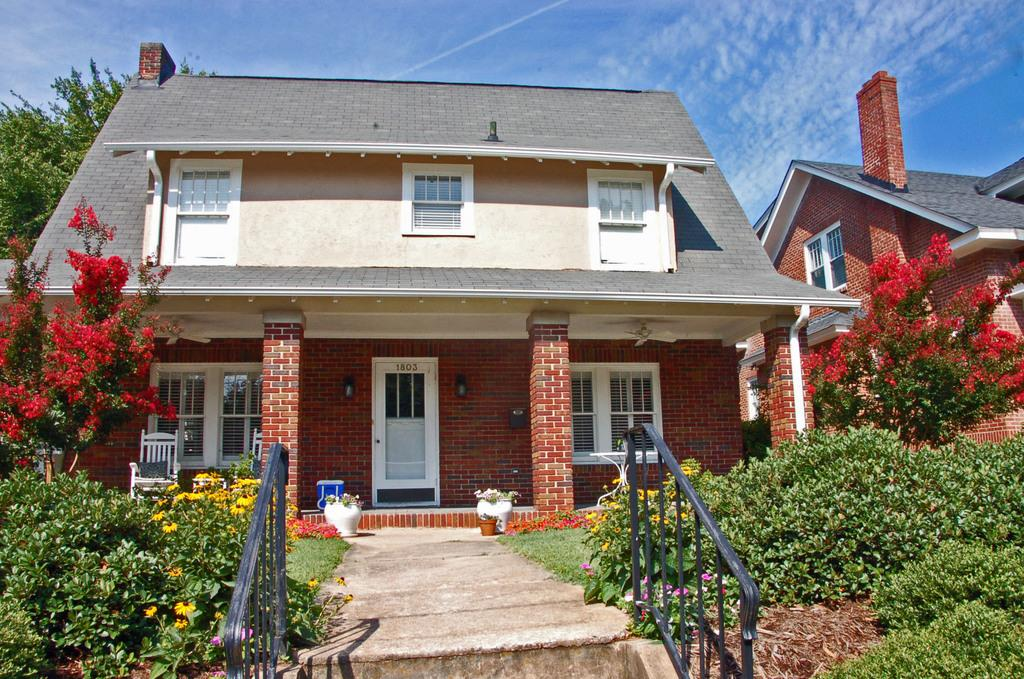What type of structures can be seen in the image? There are buildings in the image. What natural elements are present in the image? There are trees and flower plants in the image. What architectural features can be observed in the image? There are pillars in the image. What type of furniture is visible in the image? There is a chair in the image. What type of barrier is present in the image? There is a fence in the image. What other objects can be seen on the ground in the image? There are other objects on the ground in the image. What can be seen in the background of the image? The sky is visible in the background of the image. Can you hear the owl hooting in the image? There is no owl present in the image, so it is not possible to hear it hooting. What color is the ink used to write on the buildings in the image? There is no ink or writing on the buildings in the image. 